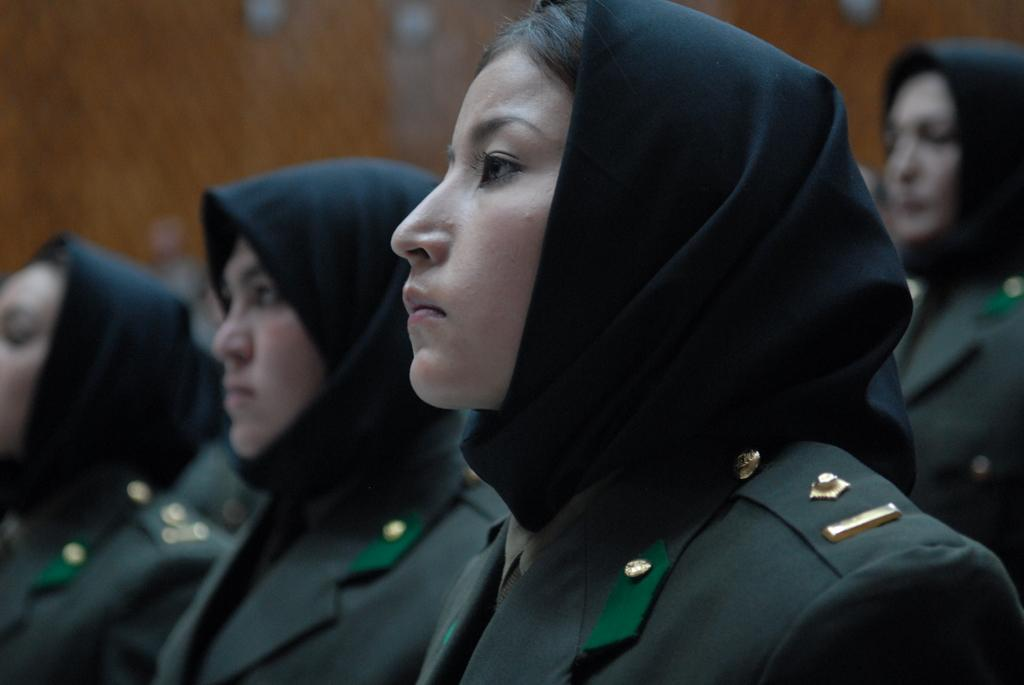How many people can be seen in the image? There are a few people in the image. What is visible in the background of the image? There is a wall visible in the background of the image. What type of oil can be seen dripping from the wood in the image? There is no oil or wood present in the image; it only features a few people and a wall in the background. 